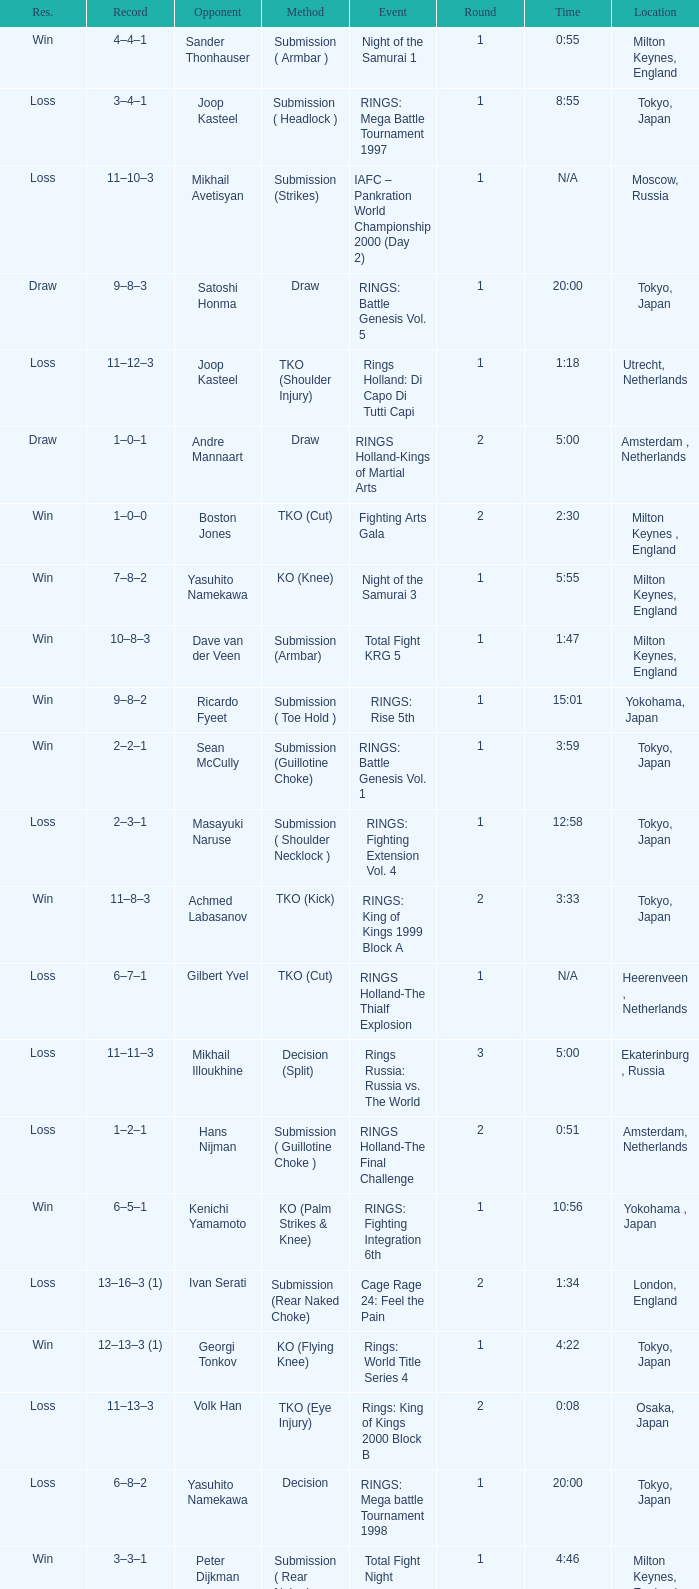What is the time for an opponent of Satoshi Honma? 20:00. 